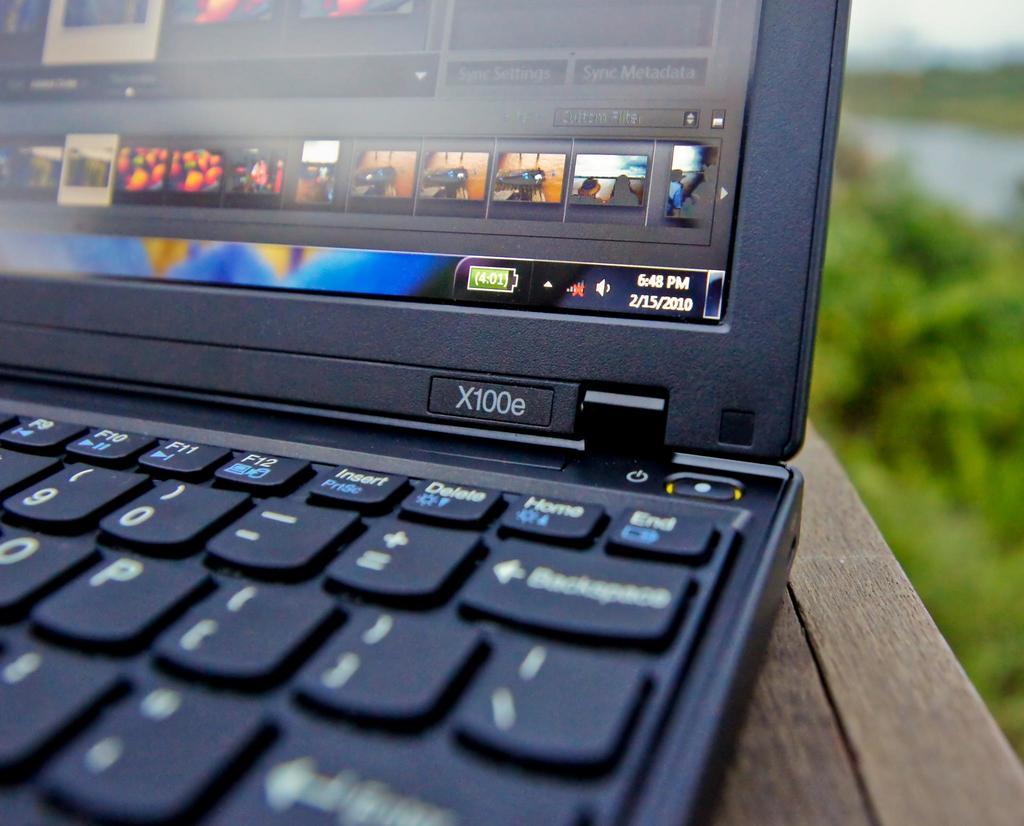What model is this laptop?
Offer a terse response. X100e. 